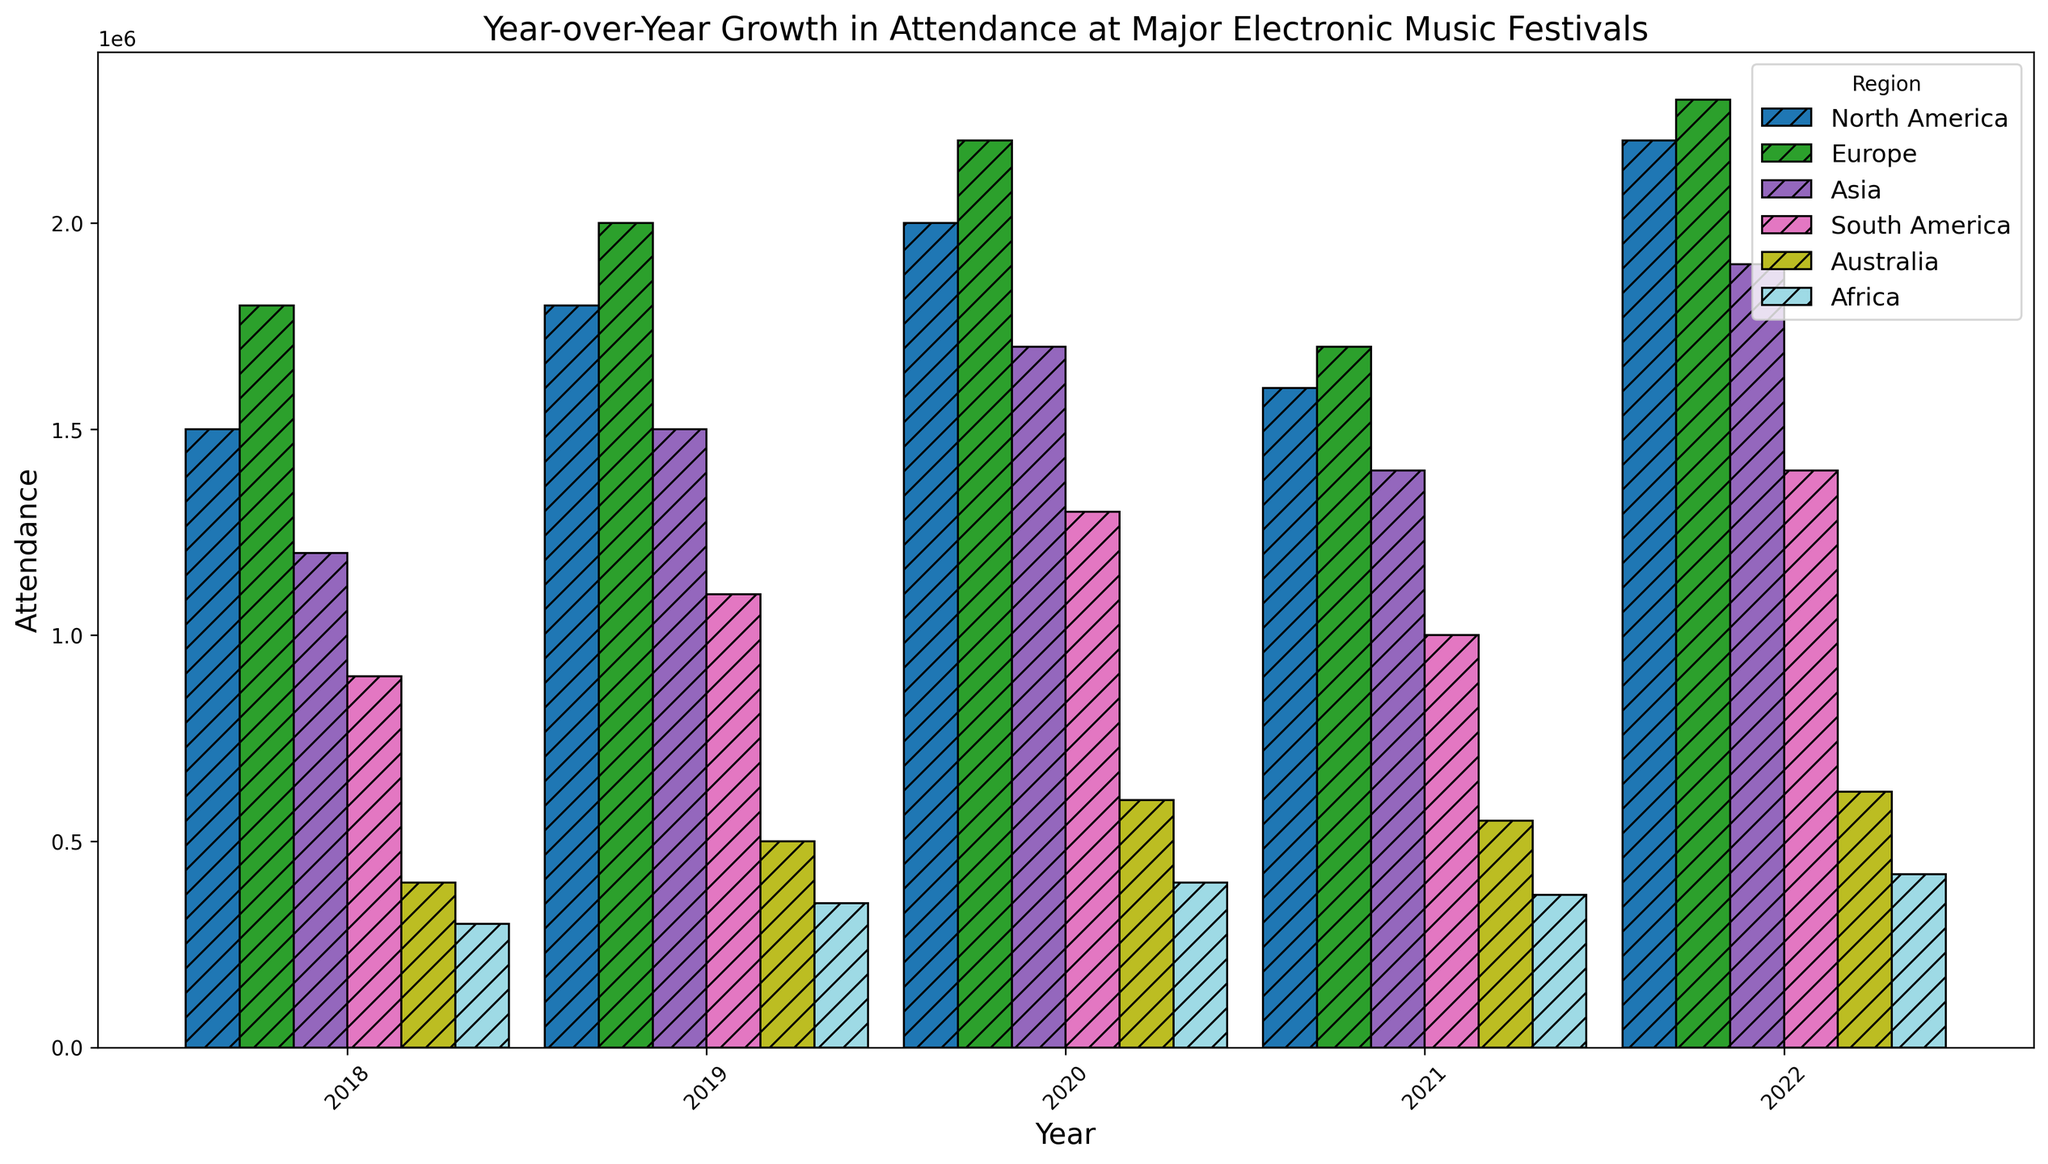What region had the highest attendance growth in 2022 compared to 2021? To find the region with the highest attendance growth in 2022 compared to 2021, observe the difference in the height of the bars for each region between the two years. North America increased from 1,600,000 to 2,200,000, Europe from 1,700,000 to 2,300,000, and so forth. Comparing these changes, Europe shows an increase of 600,000.
Answer: Europe Did any region see a decline in attendance from 2019 to 2021? Compare the heights of the bars for each region from 2019 to 2021. North America dropped from 1,800,000 in 2019 to 1,600,000 in 2021, and Europe fell from 2,000,000 in 2019 to 1,700,000 in 2021. Both Asia and South America also experienced declines, from 1,500,000 to 1,400,000 and 1,100,000 to 1,000,000, respectively.
Answer: Yes Which year had the highest overall attendance across all regions? To determine the year with the highest overall attendance, sum the heights of the bars for each year across all regions. 2022 has the tallest combined height, indicating the highest overall attendance.
Answer: 2022 How much did North America's attendance change from 2020 to 2021? Look at North America's bars for 2020 and 2021. The attendance decreased from 2,000,000 in 2020 to 1,600,000 in 2021. The difference is 2,000,000 - 1,600,000 = 400,000.
Answer: Decreased by 400,000 What was the attendance difference between Asia and South America in 2019? To find the attendance difference, compare the bar heights for both regions in 2019. Asia had 1,500,000, and South America had 1,100,000. The difference is 1,500,000 - 1,100,000 = 400,000.
Answer: 400,000 Which region had the least attendance in 2020? Identify the shortest bar in 2020. The bar for Africa is the shortest, indicating the least attendance at 400,000.
Answer: Africa How did the attendance in Europe compare to North America in 2018? Look at the bar heights for Europe and North America in 2018. Europe has 1,800,000, and North America has 1,500,000. Europe had a higher attendance.
Answer: Europe was higher What is the average annual attendance in Australia from 2018 to 2022? Sum the attendances for Australia from 2018 to 2022: 400,000 + 500,000 + 600,000 + 550,000 + 620,000 = 2,670,000. Divide by 5 years to get the average: 2,670,000 / 5 = 534,000.
Answer: 534,000 Which region showed the most consistent year-over-year growth? Assess the bar heights for each region across all the years. North America, Europe, Asia, and South America show dips, but Australia's attendance displays a consistent increase, making it the most consistent.
Answer: Australia 